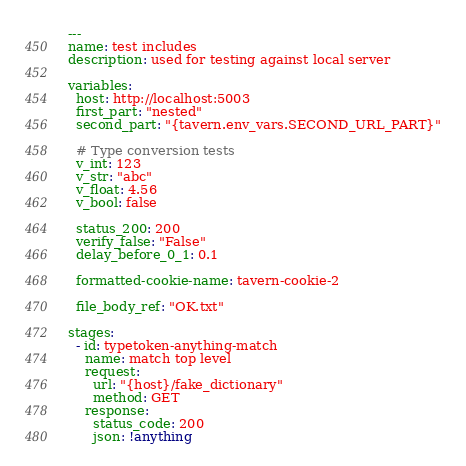Convert code to text. <code><loc_0><loc_0><loc_500><loc_500><_YAML_>---
name: test includes
description: used for testing against local server

variables:
  host: http://localhost:5003
  first_part: "nested"
  second_part: "{tavern.env_vars.SECOND_URL_PART}"

  # Type conversion tests
  v_int: 123
  v_str: "abc"
  v_float: 4.56
  v_bool: false

  status_200: 200
  verify_false: "False"
  delay_before_0_1: 0.1

  formatted-cookie-name: tavern-cookie-2

  file_body_ref: "OK.txt"

stages:
  - id: typetoken-anything-match
    name: match top level
    request:
      url: "{host}/fake_dictionary"
      method: GET
    response:
      status_code: 200
      json: !anything
</code> 